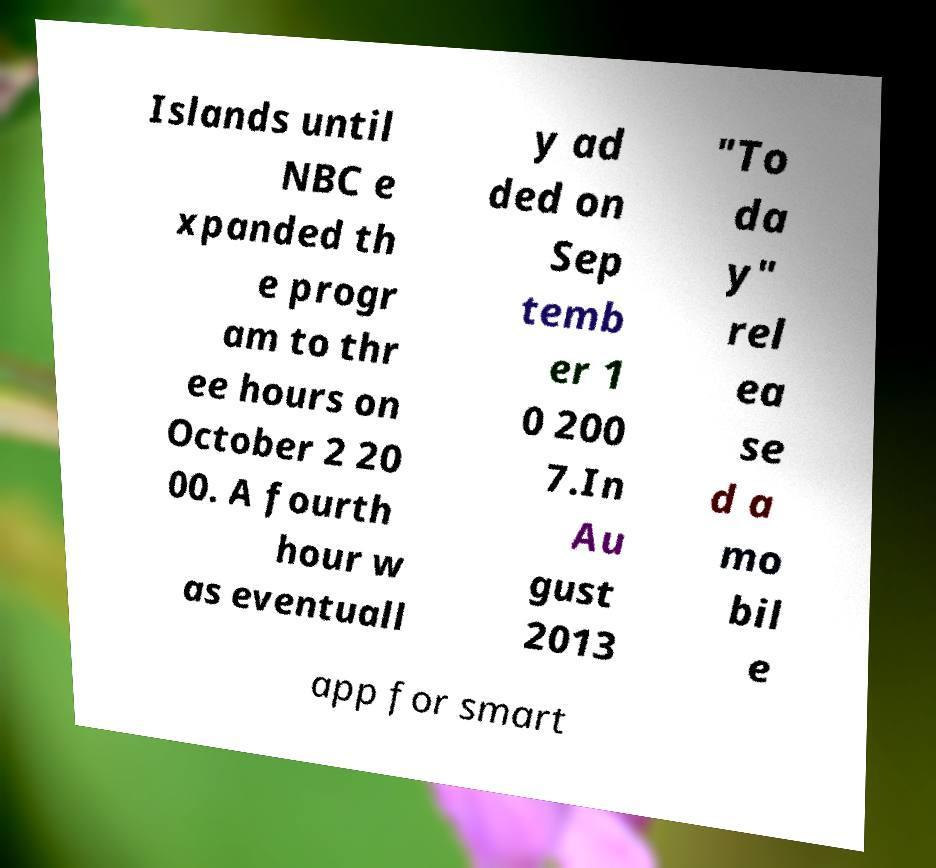Can you accurately transcribe the text from the provided image for me? Islands until NBC e xpanded th e progr am to thr ee hours on October 2 20 00. A fourth hour w as eventuall y ad ded on Sep temb er 1 0 200 7.In Au gust 2013 "To da y" rel ea se d a mo bil e app for smart 